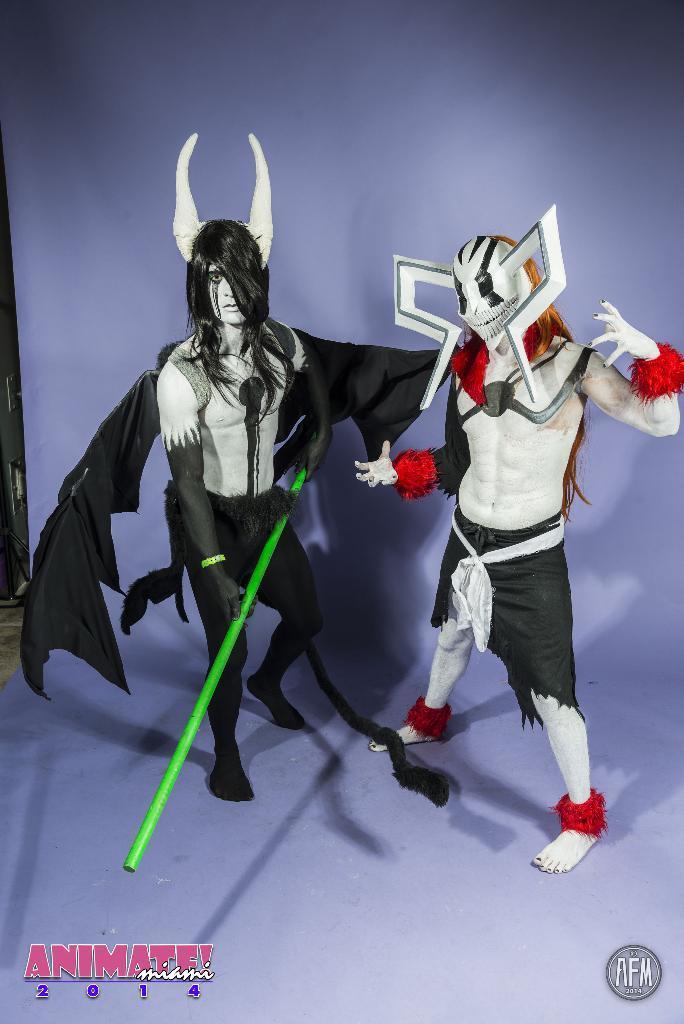How would you summarize this image in a sentence or two? In this picture I can see two people wearing different costume and standing. 